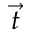<formula> <loc_0><loc_0><loc_500><loc_500>\vec { t }</formula> 